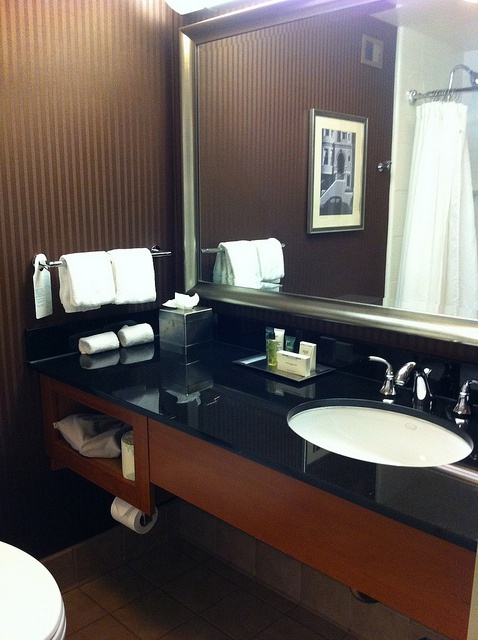Describe the objects in this image and their specific colors. I can see sink in tan, beige, black, darkgray, and darkblue tones and toilet in tan, ivory, darkgray, black, and gray tones in this image. 